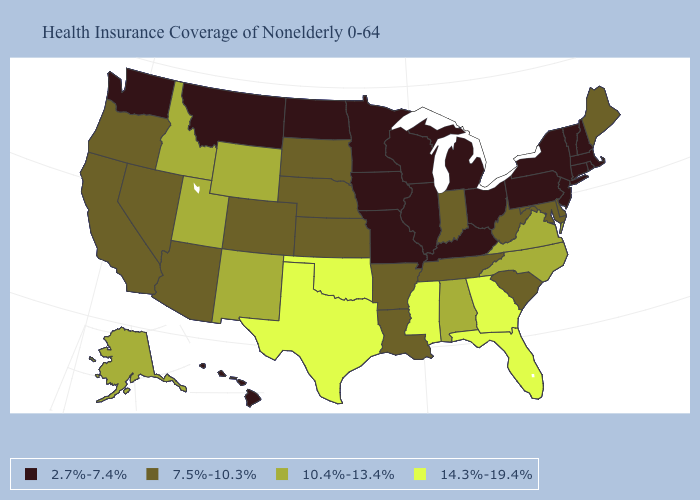What is the value of Rhode Island?
Keep it brief. 2.7%-7.4%. Among the states that border North Carolina , which have the lowest value?
Be succinct. South Carolina, Tennessee. Name the states that have a value in the range 2.7%-7.4%?
Concise answer only. Connecticut, Hawaii, Illinois, Iowa, Kentucky, Massachusetts, Michigan, Minnesota, Missouri, Montana, New Hampshire, New Jersey, New York, North Dakota, Ohio, Pennsylvania, Rhode Island, Vermont, Washington, Wisconsin. Does Arizona have the same value as Kansas?
Be succinct. Yes. Does Rhode Island have the lowest value in the USA?
Concise answer only. Yes. Among the states that border Vermont , which have the lowest value?
Quick response, please. Massachusetts, New Hampshire, New York. What is the lowest value in states that border Massachusetts?
Answer briefly. 2.7%-7.4%. Among the states that border Oklahoma , which have the lowest value?
Write a very short answer. Missouri. What is the value of Ohio?
Short answer required. 2.7%-7.4%. What is the highest value in states that border Delaware?
Concise answer only. 7.5%-10.3%. Which states have the lowest value in the USA?
Keep it brief. Connecticut, Hawaii, Illinois, Iowa, Kentucky, Massachusetts, Michigan, Minnesota, Missouri, Montana, New Hampshire, New Jersey, New York, North Dakota, Ohio, Pennsylvania, Rhode Island, Vermont, Washington, Wisconsin. Among the states that border West Virginia , which have the highest value?
Be succinct. Virginia. Name the states that have a value in the range 10.4%-13.4%?
Concise answer only. Alabama, Alaska, Idaho, New Mexico, North Carolina, Utah, Virginia, Wyoming. How many symbols are there in the legend?
Quick response, please. 4. What is the value of New Jersey?
Keep it brief. 2.7%-7.4%. 